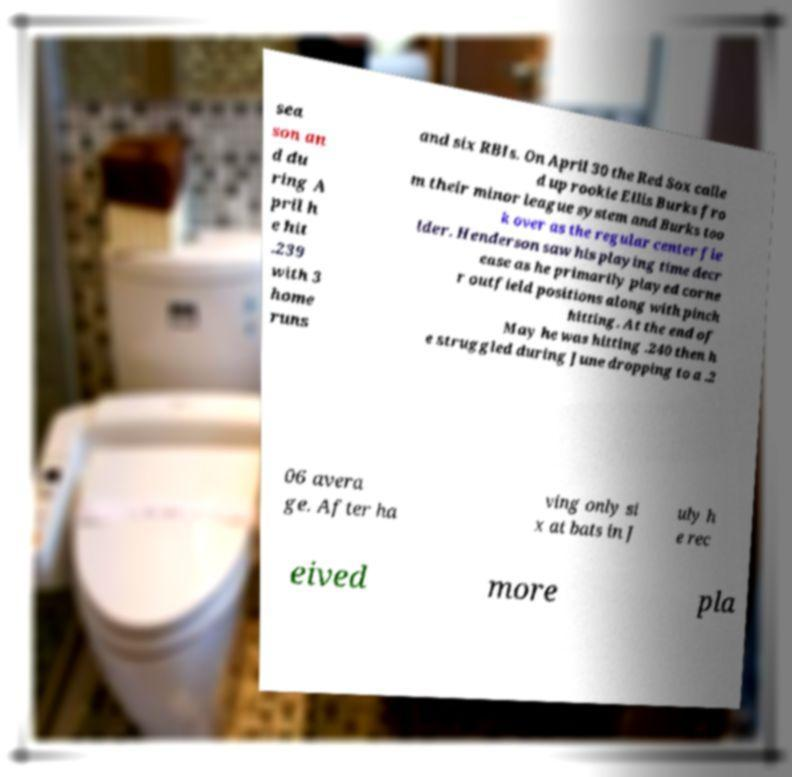Can you read and provide the text displayed in the image?This photo seems to have some interesting text. Can you extract and type it out for me? sea son an d du ring A pril h e hit .239 with 3 home runs and six RBIs. On April 30 the Red Sox calle d up rookie Ellis Burks fro m their minor league system and Burks too k over as the regular center fie lder. Henderson saw his playing time decr ease as he primarily played corne r outfield positions along with pinch hitting. At the end of May he was hitting .240 then h e struggled during June dropping to a .2 06 avera ge. After ha ving only si x at bats in J uly h e rec eived more pla 